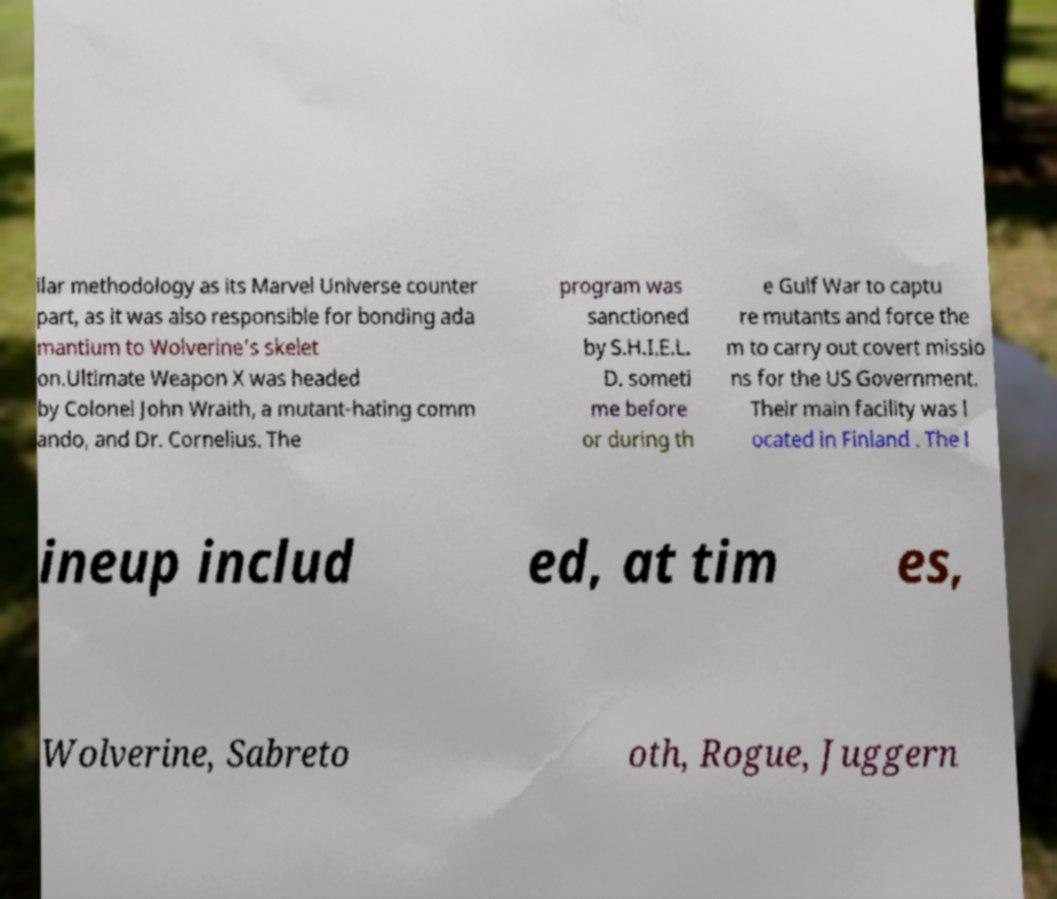Can you accurately transcribe the text from the provided image for me? ilar methodology as its Marvel Universe counter part, as it was also responsible for bonding ada mantium to Wolverine’s skelet on.Ultimate Weapon X was headed by Colonel John Wraith, a mutant-hating comm ando, and Dr. Cornelius. The program was sanctioned by S.H.I.E.L. D. someti me before or during th e Gulf War to captu re mutants and force the m to carry out covert missio ns for the US Government. Their main facility was l ocated in Finland . The l ineup includ ed, at tim es, Wolverine, Sabreto oth, Rogue, Juggern 